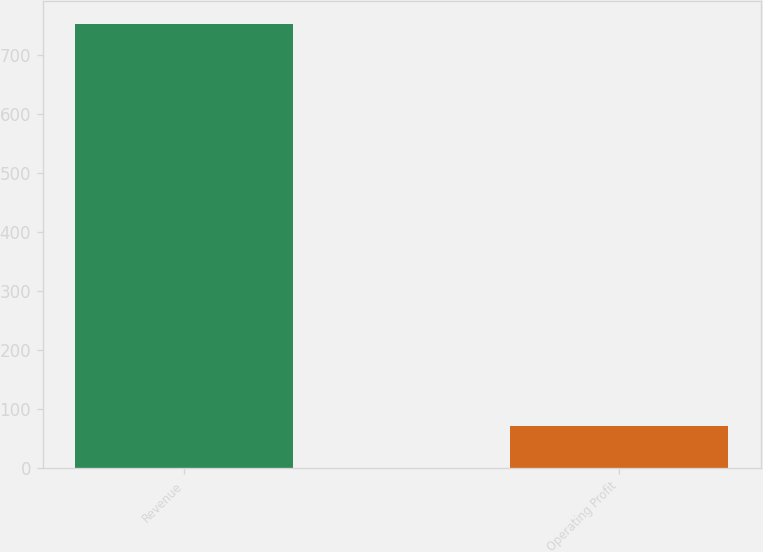Convert chart. <chart><loc_0><loc_0><loc_500><loc_500><bar_chart><fcel>Revenue<fcel>Operating Profit<nl><fcel>753.4<fcel>71.6<nl></chart> 